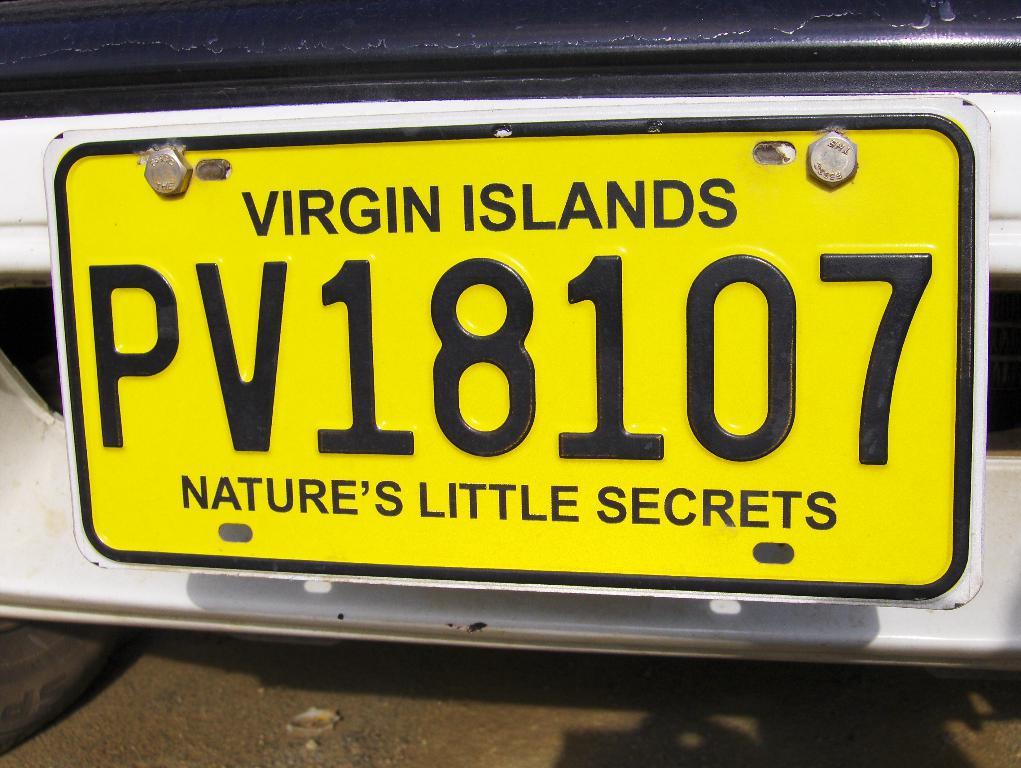What country is the license plate from?
Ensure brevity in your answer.  Virgin islands. What motto is on the bottom of the license plate?
Your answer should be very brief. Nature's little secrets. 